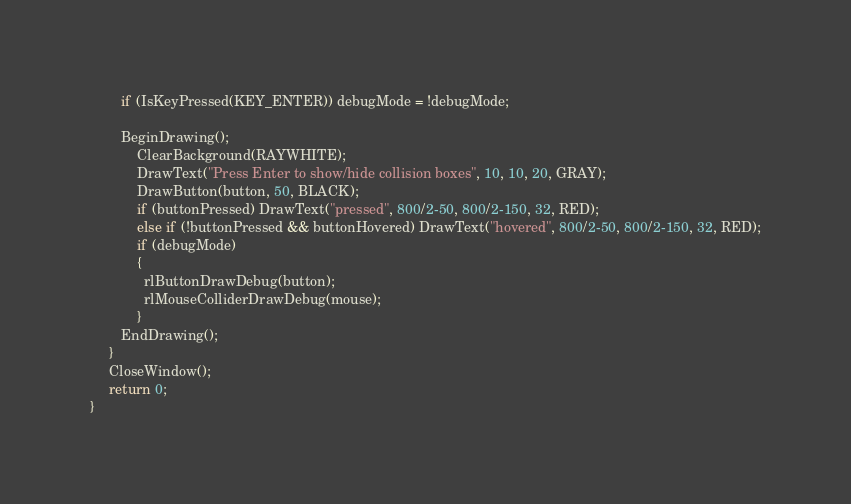<code> <loc_0><loc_0><loc_500><loc_500><_C_>        if (IsKeyPressed(KEY_ENTER)) debugMode = !debugMode;
        
        BeginDrawing();
            ClearBackground(RAYWHITE);
            DrawText("Press Enter to show/hide collision boxes", 10, 10, 20, GRAY);
            DrawButton(button, 50, BLACK);
            if (buttonPressed) DrawText("pressed", 800/2-50, 800/2-150, 32, RED);
            else if (!buttonPressed && buttonHovered) DrawText("hovered", 800/2-50, 800/2-150, 32, RED);
            if (debugMode) 
            {
              rlButtonDrawDebug(button);
              rlMouseColliderDrawDebug(mouse);
            }
        EndDrawing();
     }
     CloseWindow();
     return 0;
}
</code> 